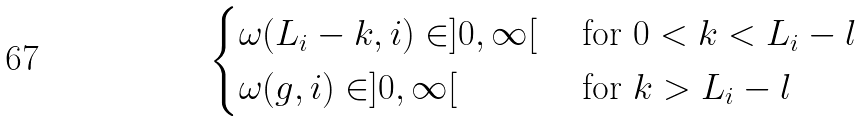<formula> <loc_0><loc_0><loc_500><loc_500>\begin{cases} \omega ( L _ { i } - k , i ) \in ] 0 , \infty [ & \text { for $0<k<L_{i}-l$} \\ \omega ( g , i ) \in ] 0 , \infty [ & \text { for $k>L_{i}-l$} \end{cases}</formula> 